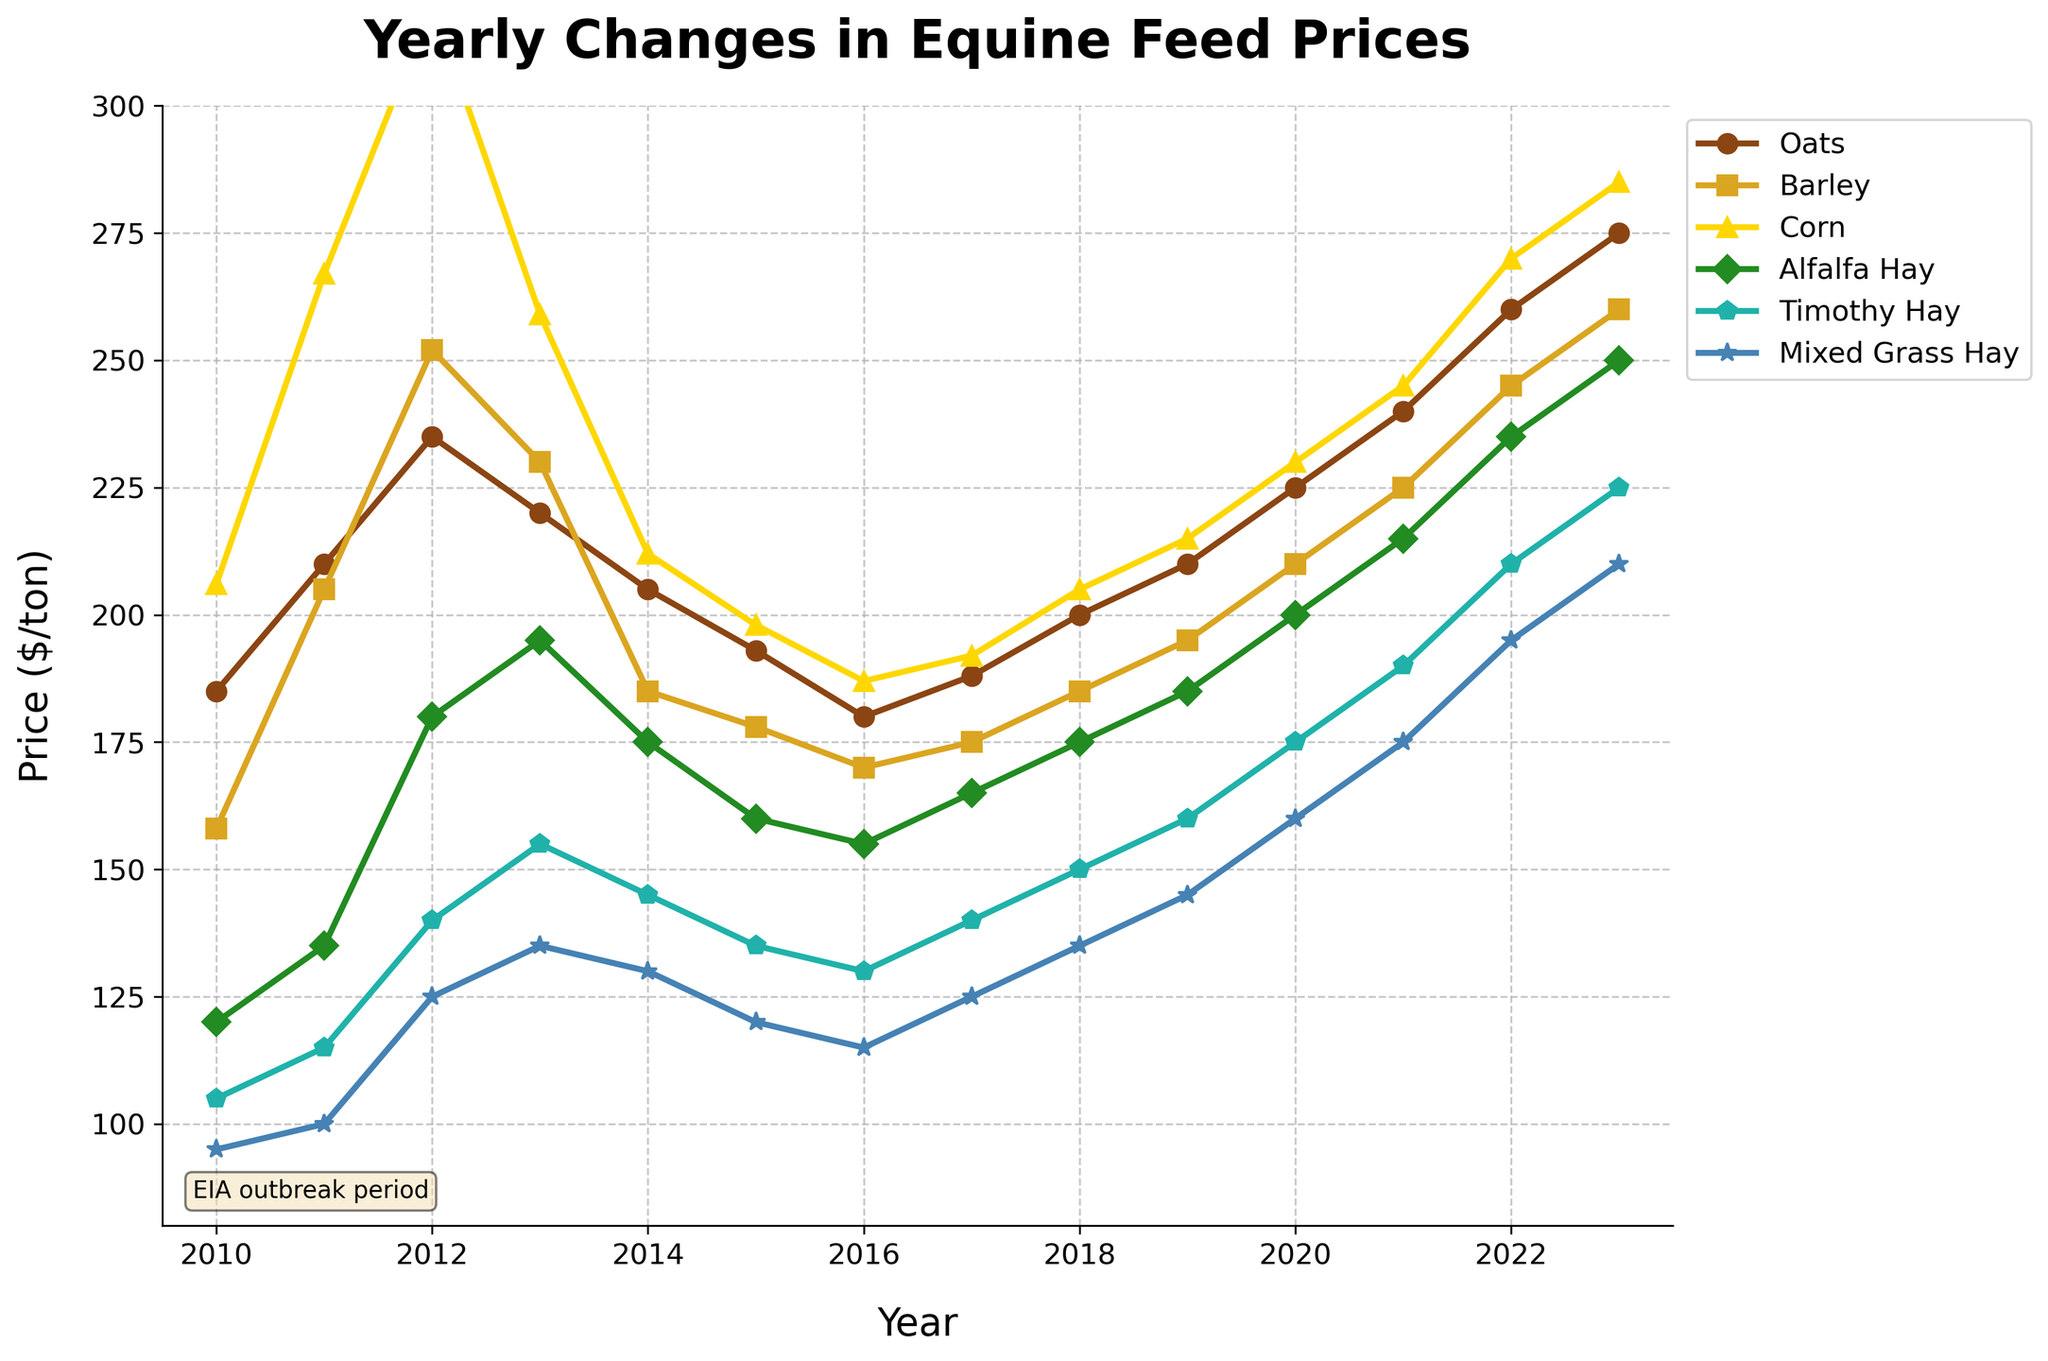What was the price of Oats in 2014? The price of Oats in the year 2014 can be found by locating the point on the line representing Oats for the year 2014.
Answer: 205 How much did the price of Corn increase from 2010 to 2023? To find the increase, subtract the price of Corn in 2010 from the price in 2023: 285 - 206.
Answer: 79 Which feed had the highest price in 2023? The feed with the highest price in 2023 is indicated by the marker highest on the y-axis next to the year 2023.
Answer: Corn When did Alfalfa Hay first reach a price of $200 per ton? Identify the year where the line representing Alfalfa Hay crosses the y-axis value of 200.
Answer: 2020 Comparing Barley and Timothy Hay prices in 2011, which was higher? Locate the points representing Barley and Timothy Hay for 2011 and compare their positions on the y-axis.
Answer: Barley What’s the average price of Timothy Hay during the first five years? Calculate the average by summing the prices of Timothy Hay from 2010 to 2014 and dividing by 5: (105 + 115 + 140 + 155 + 145)/5.
Answer: 132 Between which years did Mixed Grass Hay experience the largest price increase? Look for the largest positive difference between consecutive data points for Mixed Grass Hay.
Answer: 2020-2021 By how much did the price of Oats fluctuated from 2011 to 2016? Oats price in 2011 was 210 and in 2016 it was 180. Calculate the absolute difference: 210 - 180.
Answer: 30 What color represents the line for Barley? Identify the color of the line or markers used to represent Barley in the plot.
Answer: Gold In which year did Alfalfa Hay witness a significant price drop and how much was it? Identify the year where there is a noticeable drop in the Alfalfa Hay line and calculate the price difference between the two years around the drop: 2013 and 2014, 195 - 175.
Answer: 2014, 20 